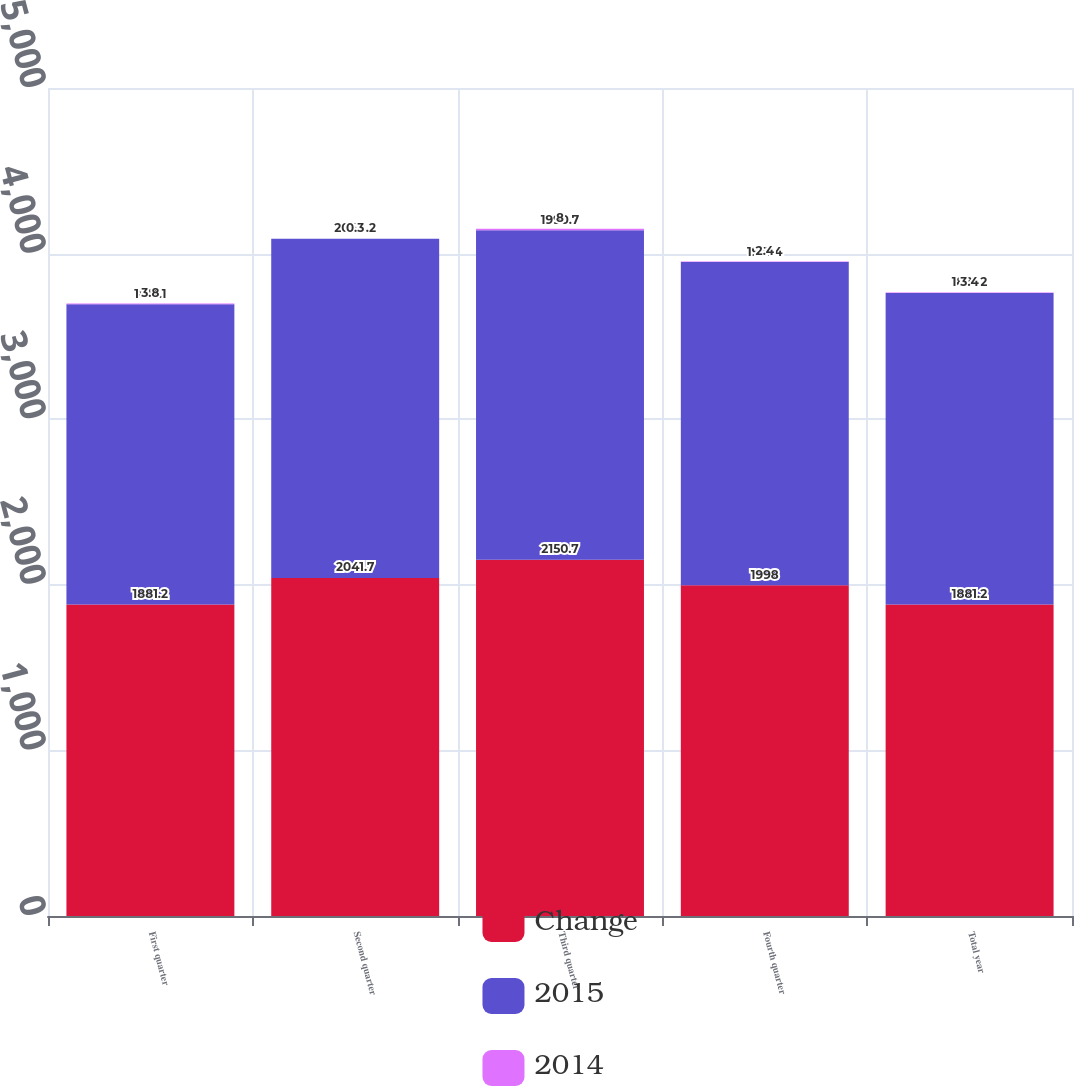Convert chart to OTSL. <chart><loc_0><loc_0><loc_500><loc_500><stacked_bar_chart><ecel><fcel>First quarter<fcel>Second quarter<fcel>Third quarter<fcel>Fourth quarter<fcel>Total year<nl><fcel>Change<fcel>1881.2<fcel>2041.7<fcel>2150.7<fcel>1998<fcel>1881.2<nl><fcel>2015<fcel>1813.1<fcel>2048.2<fcel>1990.7<fcel>1951.4<fcel>1881.2<nl><fcel>2014<fcel>3.8<fcel>0.3<fcel>8<fcel>2.4<fcel>3.4<nl></chart> 